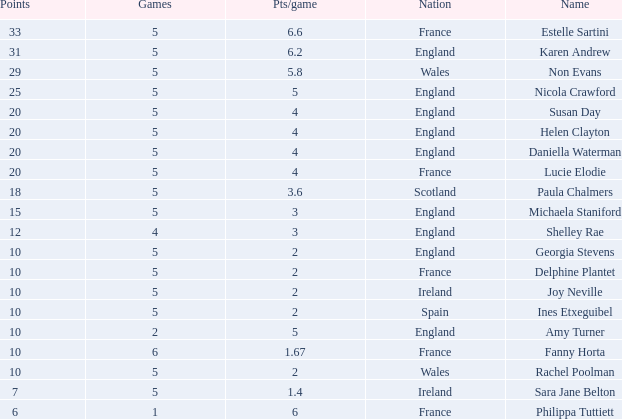Can you tell me the lowest Pts/game that has the Games larger than 6? None. 